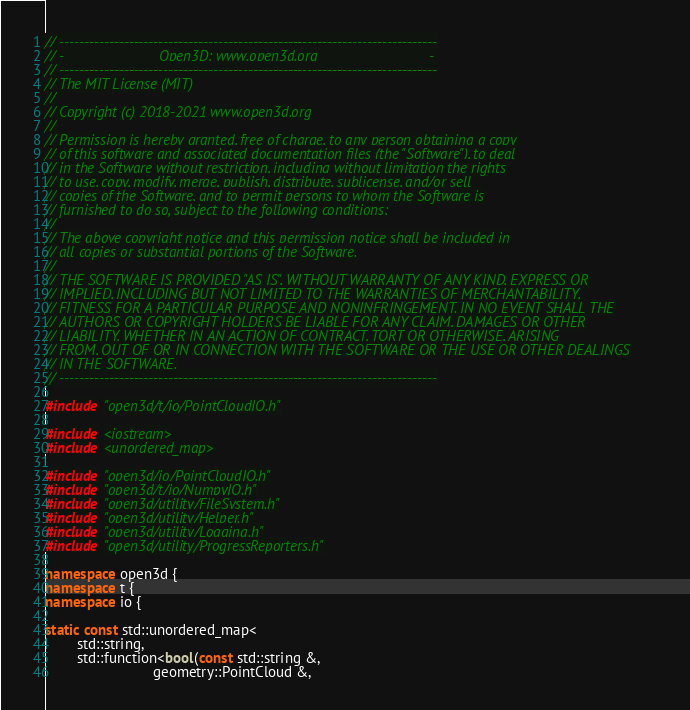<code> <loc_0><loc_0><loc_500><loc_500><_C++_>// ----------------------------------------------------------------------------
// -                        Open3D: www.open3d.org                            -
// ----------------------------------------------------------------------------
// The MIT License (MIT)
//
// Copyright (c) 2018-2021 www.open3d.org
//
// Permission is hereby granted, free of charge, to any person obtaining a copy
// of this software and associated documentation files (the "Software"), to deal
// in the Software without restriction, including without limitation the rights
// to use, copy, modify, merge, publish, distribute, sublicense, and/or sell
// copies of the Software, and to permit persons to whom the Software is
// furnished to do so, subject to the following conditions:
//
// The above copyright notice and this permission notice shall be included in
// all copies or substantial portions of the Software.
//
// THE SOFTWARE IS PROVIDED "AS IS", WITHOUT WARRANTY OF ANY KIND, EXPRESS OR
// IMPLIED, INCLUDING BUT NOT LIMITED TO THE WARRANTIES OF MERCHANTABILITY,
// FITNESS FOR A PARTICULAR PURPOSE AND NONINFRINGEMENT. IN NO EVENT SHALL THE
// AUTHORS OR COPYRIGHT HOLDERS BE LIABLE FOR ANY CLAIM, DAMAGES OR OTHER
// LIABILITY, WHETHER IN AN ACTION OF CONTRACT, TORT OR OTHERWISE, ARISING
// FROM, OUT OF OR IN CONNECTION WITH THE SOFTWARE OR THE USE OR OTHER DEALINGS
// IN THE SOFTWARE.
// ----------------------------------------------------------------------------

#include "open3d/t/io/PointCloudIO.h"

#include <iostream>
#include <unordered_map>

#include "open3d/io/PointCloudIO.h"
#include "open3d/t/io/NumpyIO.h"
#include "open3d/utility/FileSystem.h"
#include "open3d/utility/Helper.h"
#include "open3d/utility/Logging.h"
#include "open3d/utility/ProgressReporters.h"

namespace open3d {
namespace t {
namespace io {

static const std::unordered_map<
        std::string,
        std::function<bool(const std::string &,
                           geometry::PointCloud &,</code> 